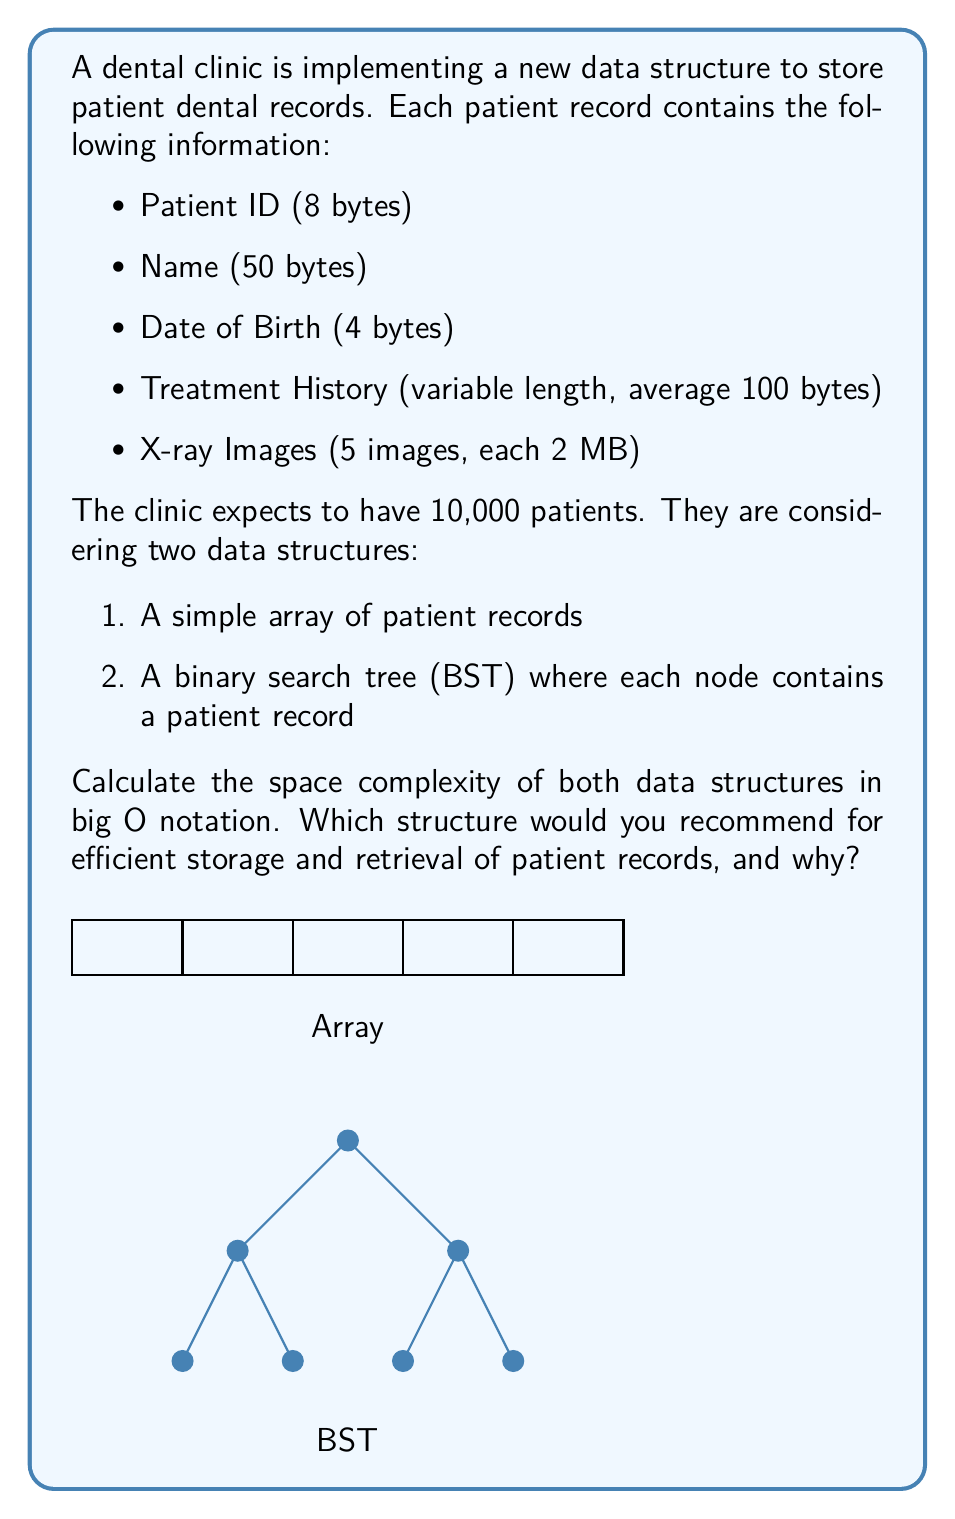Teach me how to tackle this problem. Let's analyze the space complexity of both data structures step by step:

1. Calculate the size of a single patient record:
   - Patient ID: 8 bytes
   - Name: 50 bytes
   - Date of Birth: 4 bytes
   - Treatment History: 100 bytes (average)
   - X-ray Images: 5 * 2 MB = 10 MB = 10,000,000 bytes
   Total: 8 + 50 + 4 + 100 + 10,000,000 = 10,000,162 bytes ≈ 10 MB

2. Array structure:
   - Space required = Number of patients * Size of each record
   - Space = 10,000 * 10 MB = 100,000 MB = 100 GB
   - Space complexity: $O(n)$, where n is the number of patients

3. Binary Search Tree (BST) structure:
   - Each node in the BST contains a patient record and two pointers (left and right child)
   - Size of pointers: Assuming 64-bit system, each pointer is 8 bytes
   - Space for each node = Size of patient record + 2 * 8 bytes = 10 MB + 16 bytes ≈ 10 MB
   - Total space = Number of patients * Space for each node
   - Space = 10,000 * 10 MB = 100,000 MB = 100 GB
   - Space complexity: $O(n)$, where n is the number of patients

Both data structures have a space complexity of $O(n)$. However, the BST offers better time complexity for searching, inserting, and deleting records (average case $O(\log n)$ vs. $O(n)$ for an unsorted array).

Recommendation:
The Binary Search Tree (BST) is recommended for efficient storage and retrieval of patient records because:
1. It maintains the same space complexity as the array $(O(n))$.
2. It provides faster search, insert, and delete operations (average case $O(\log n)$).
3. It allows for efficient range queries (e.g., finding patients within a certain age range).
4. It can be balanced (e.g., using AVL or Red-Black trees) to ensure $O(\log n)$ worst-case time complexity for operations.

The slight increase in space due to the additional pointers (16 bytes per record) is negligible compared to the size of the patient records (10 MB) and is outweighed by the improved time efficiency for operations.
Answer: $O(n)$ for both; BST recommended for efficient operations. 